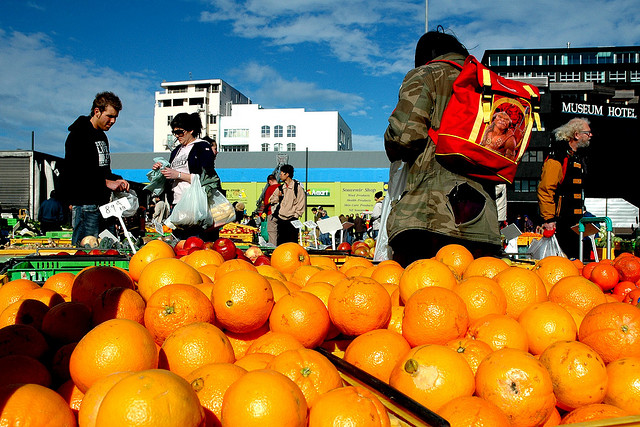Read and extract the text from this image. MUSEUM HOTEL 